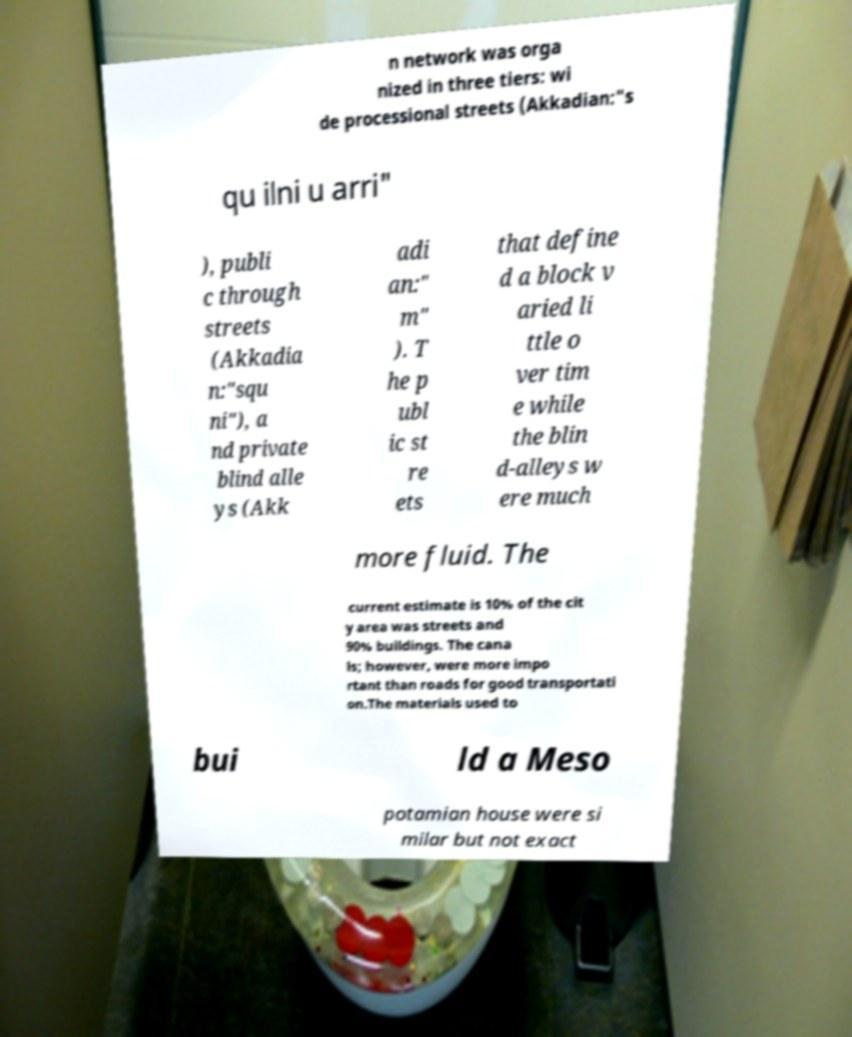For documentation purposes, I need the text within this image transcribed. Could you provide that? n network was orga nized in three tiers: wi de processional streets (Akkadian:"s qu ilni u arri" ), publi c through streets (Akkadia n:"squ ni"), a nd private blind alle ys (Akk adi an:" m" ). T he p ubl ic st re ets that define d a block v aried li ttle o ver tim e while the blin d-alleys w ere much more fluid. The current estimate is 10% of the cit y area was streets and 90% buildings. The cana ls; however, were more impo rtant than roads for good transportati on.The materials used to bui ld a Meso potamian house were si milar but not exact 